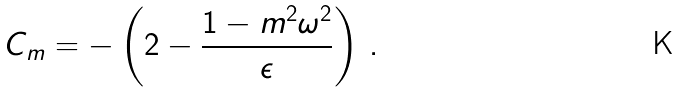<formula> <loc_0><loc_0><loc_500><loc_500>C _ { m } = - \left ( 2 - \frac { 1 - m ^ { 2 } \omega ^ { 2 } } { \epsilon } \right ) \, .</formula> 